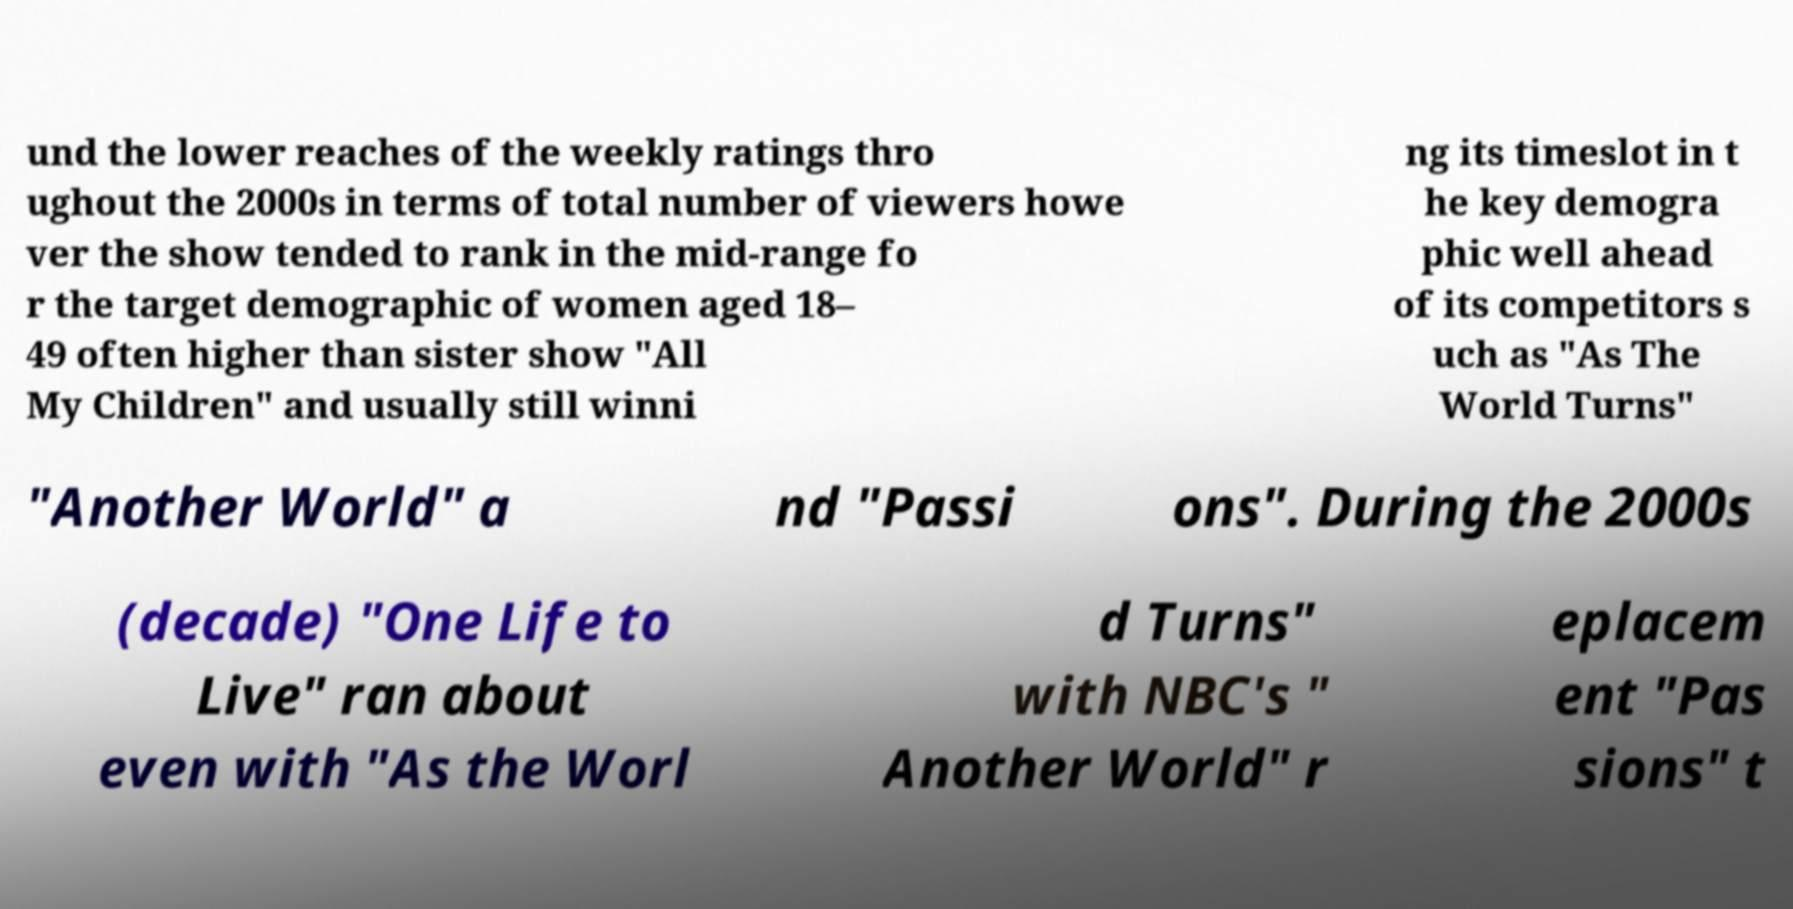For documentation purposes, I need the text within this image transcribed. Could you provide that? und the lower reaches of the weekly ratings thro ughout the 2000s in terms of total number of viewers howe ver the show tended to rank in the mid-range fo r the target demographic of women aged 18– 49 often higher than sister show "All My Children" and usually still winni ng its timeslot in t he key demogra phic well ahead of its competitors s uch as "As The World Turns" "Another World" a nd "Passi ons". During the 2000s (decade) "One Life to Live" ran about even with "As the Worl d Turns" with NBC's " Another World" r eplacem ent "Pas sions" t 